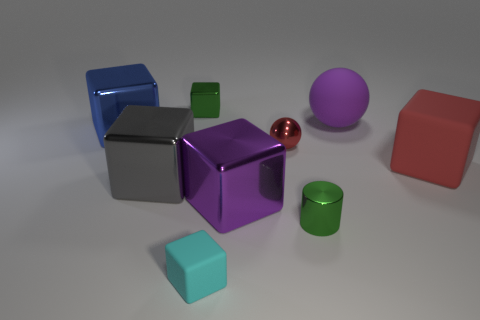Subtract 3 cubes. How many cubes are left? 3 Subtract all small cubes. How many cubes are left? 4 Subtract all red cubes. How many cubes are left? 5 Subtract all blue blocks. Subtract all red cylinders. How many blocks are left? 5 Add 1 small red metallic things. How many objects exist? 10 Subtract all cylinders. How many objects are left? 8 Subtract 1 purple cubes. How many objects are left? 8 Subtract all small red spheres. Subtract all red things. How many objects are left? 6 Add 3 matte things. How many matte things are left? 6 Add 6 red metallic balls. How many red metallic balls exist? 7 